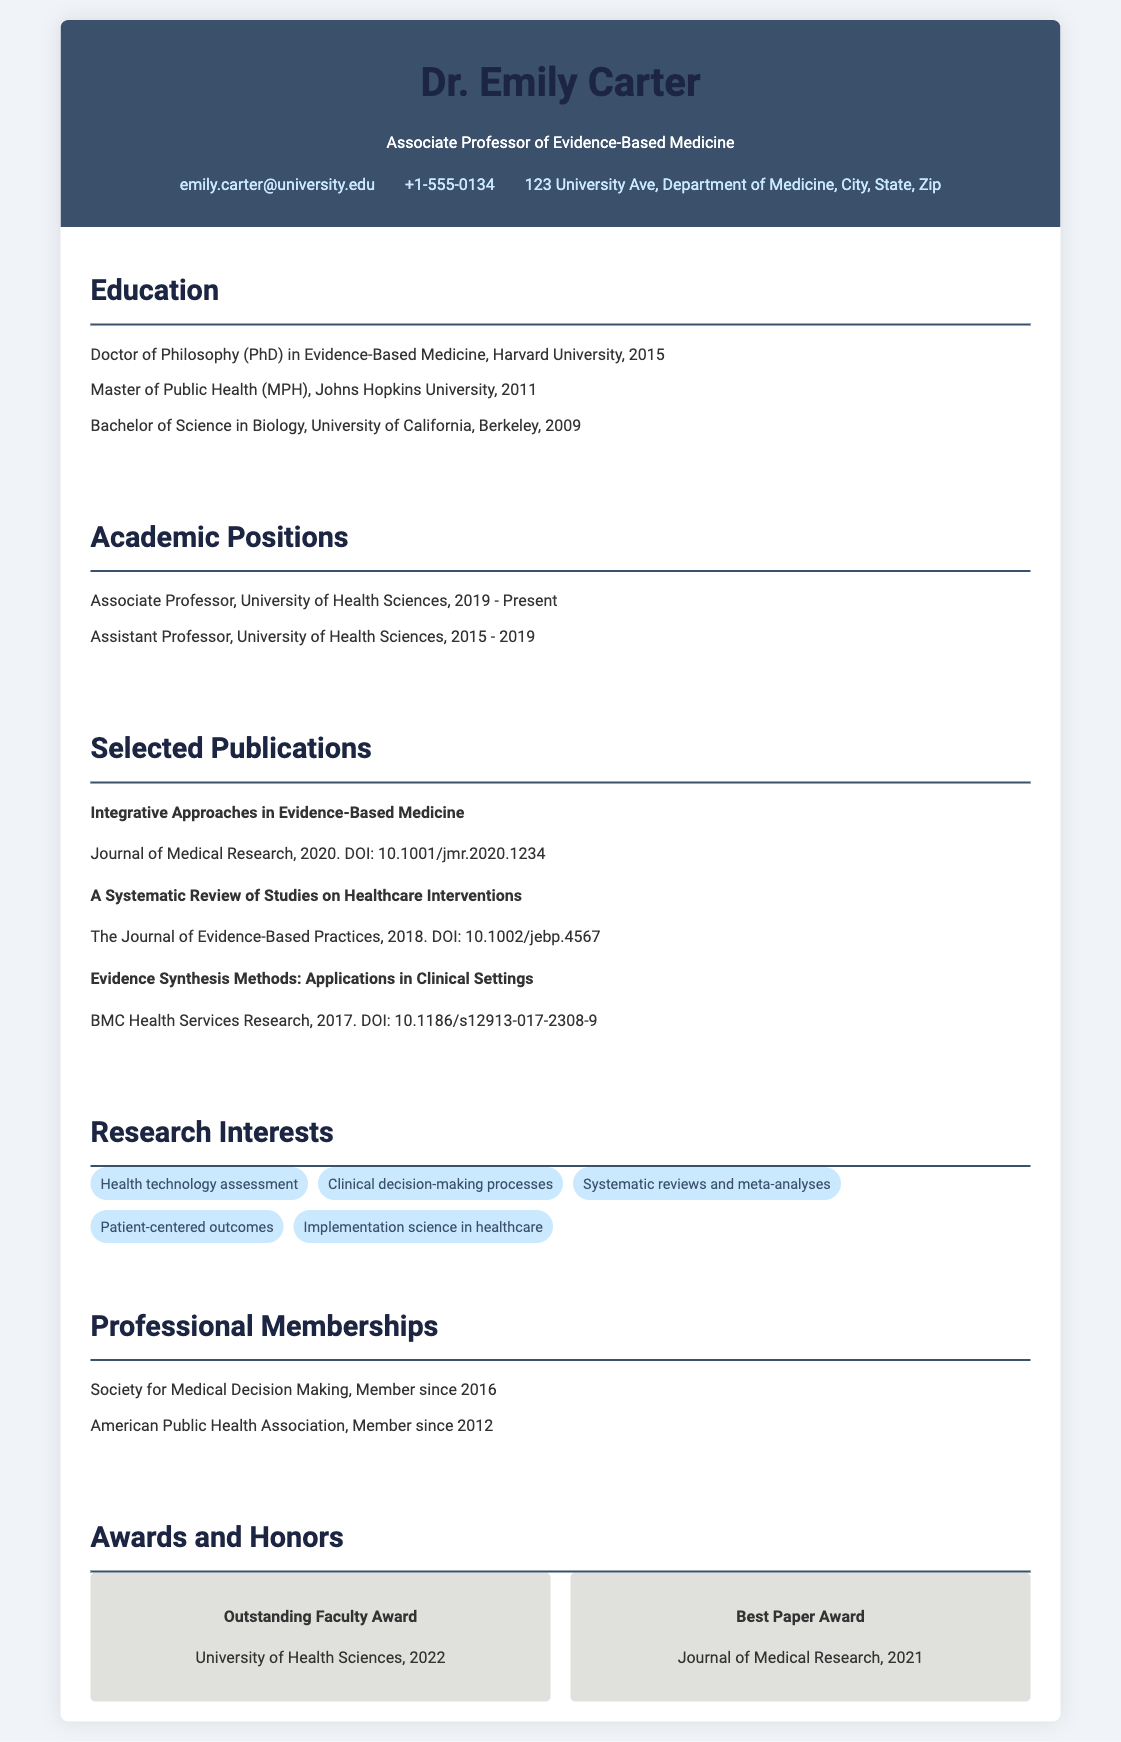What is Dr. Emily Carter's current position? The document states that she is currently an Associate Professor at the University of Health Sciences.
Answer: Associate Professor What year did Dr. Carter receive her PhD? The document mentions that she obtained her PhD in Evidence-Based Medicine in 2015.
Answer: 2015 How many selected publications are listed in the CV? There are three selected publications detailed in the CV section.
Answer: 3 What is one of Dr. Carter's research interests? The document lists several research interests, one of which is "Health technology assessment."
Answer: Health technology assessment Which award did Dr. Carter receive from the University of Health Sciences in 2022? The CV highlights that she received the Outstanding Faculty Award in 2022.
Answer: Outstanding Faculty Award How long did Dr. Carter serve as an Assistant Professor? The document indicates she held this position from 2015 to 2019, totaling four years.
Answer: 4 years What organization was Dr. Carter a member of since 2016? The document states she is a member of the Society for Medical Decision Making.
Answer: Society for Medical Decision Making What degree did Dr. Carter earn from Johns Hopkins University? The diploma listed is Master of Public Health (MPH).
Answer: Master of Public Health (MPH) What is the title of the publication from 2020? The title mentioned for the 2020 publication is "Integrative Approaches in Evidence-Based Medicine."
Answer: Integrative Approaches in Evidence-Based Medicine 